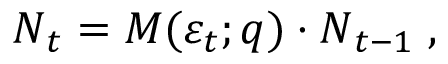<formula> <loc_0><loc_0><loc_500><loc_500>N _ { t } = M ( \varepsilon _ { t } ; q ) \cdot N _ { t - 1 } \, ,</formula> 